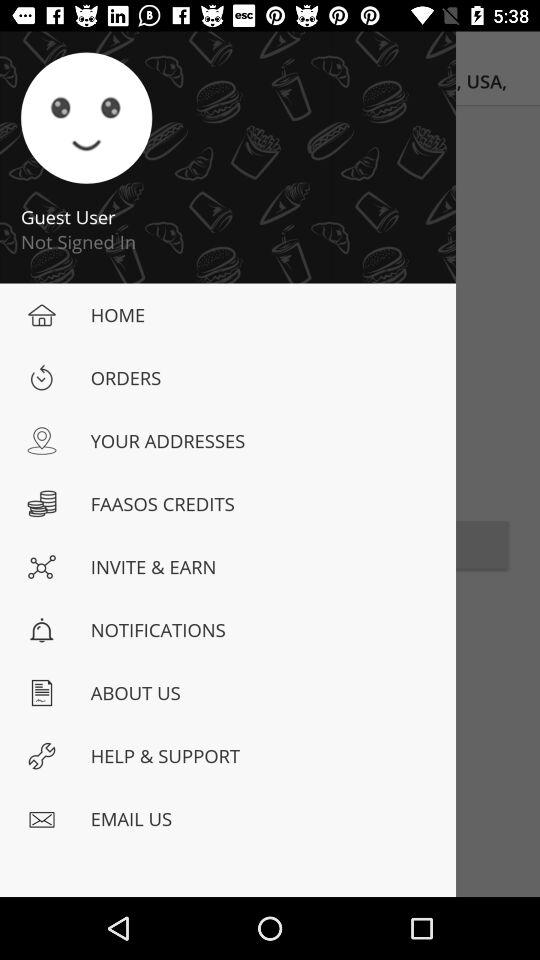What's the Profiler Name?
When the provided information is insufficient, respond with <no answer>. <no answer> 